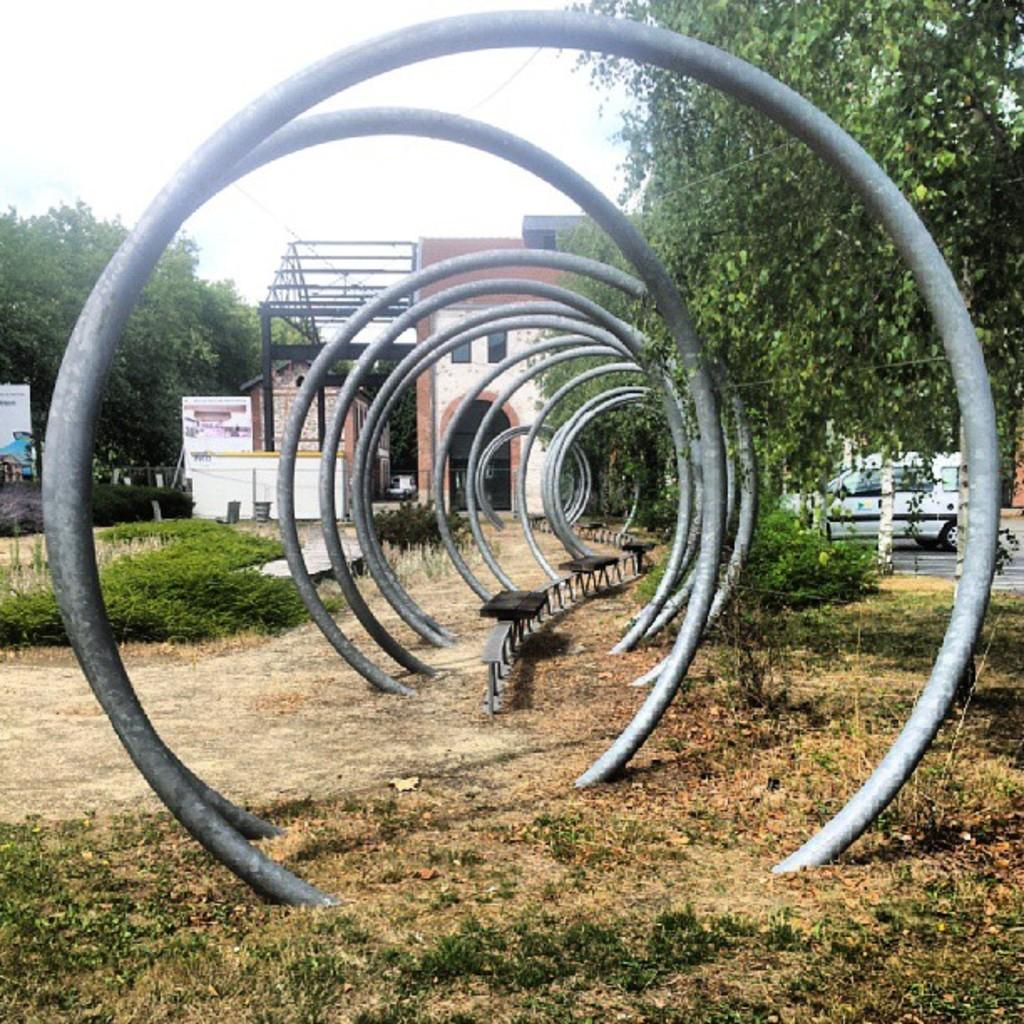What type of objects are circular and made of metal in the image? There are circular metal objects in the image. What type of seating is available in the image? There are benches in the image. What type of vegetation is present in the image? There is grass in the image. What type of natural elements are present in the image? There are trees in the image. What type of sign or information board is present in the image? There is a board in the image. What type of man-made structures are present in the image? There are buildings in the image. What type of transportation is present in the image? There is a vehicle in the image. What can be seen in the background of the image? The sky is visible in the background of the image. How does the growth of the trees affect the toe of the person in the image? There is no person present in the image, and therefore no toes to be affected by the growth of the trees. 